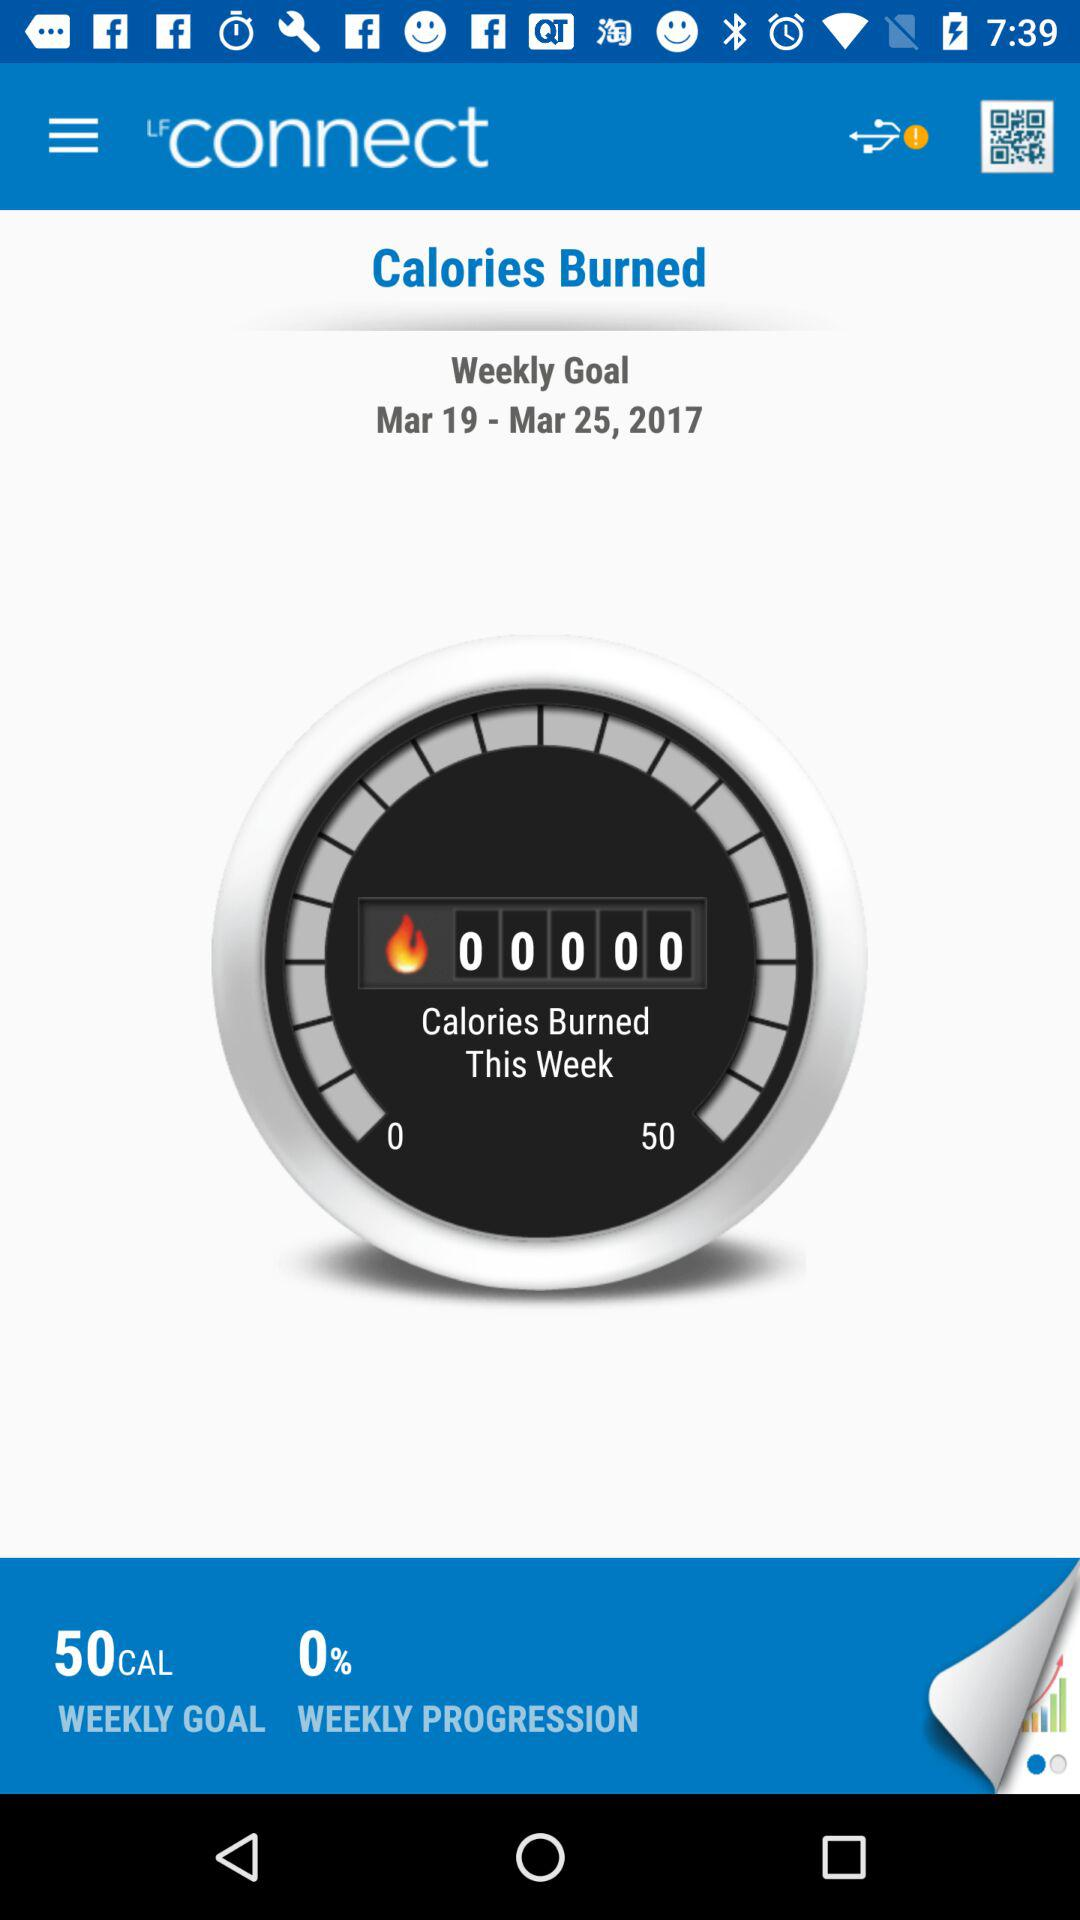How many more calories does the user need to burn to reach their weekly goal?
Answer the question using a single word or phrase. 50 